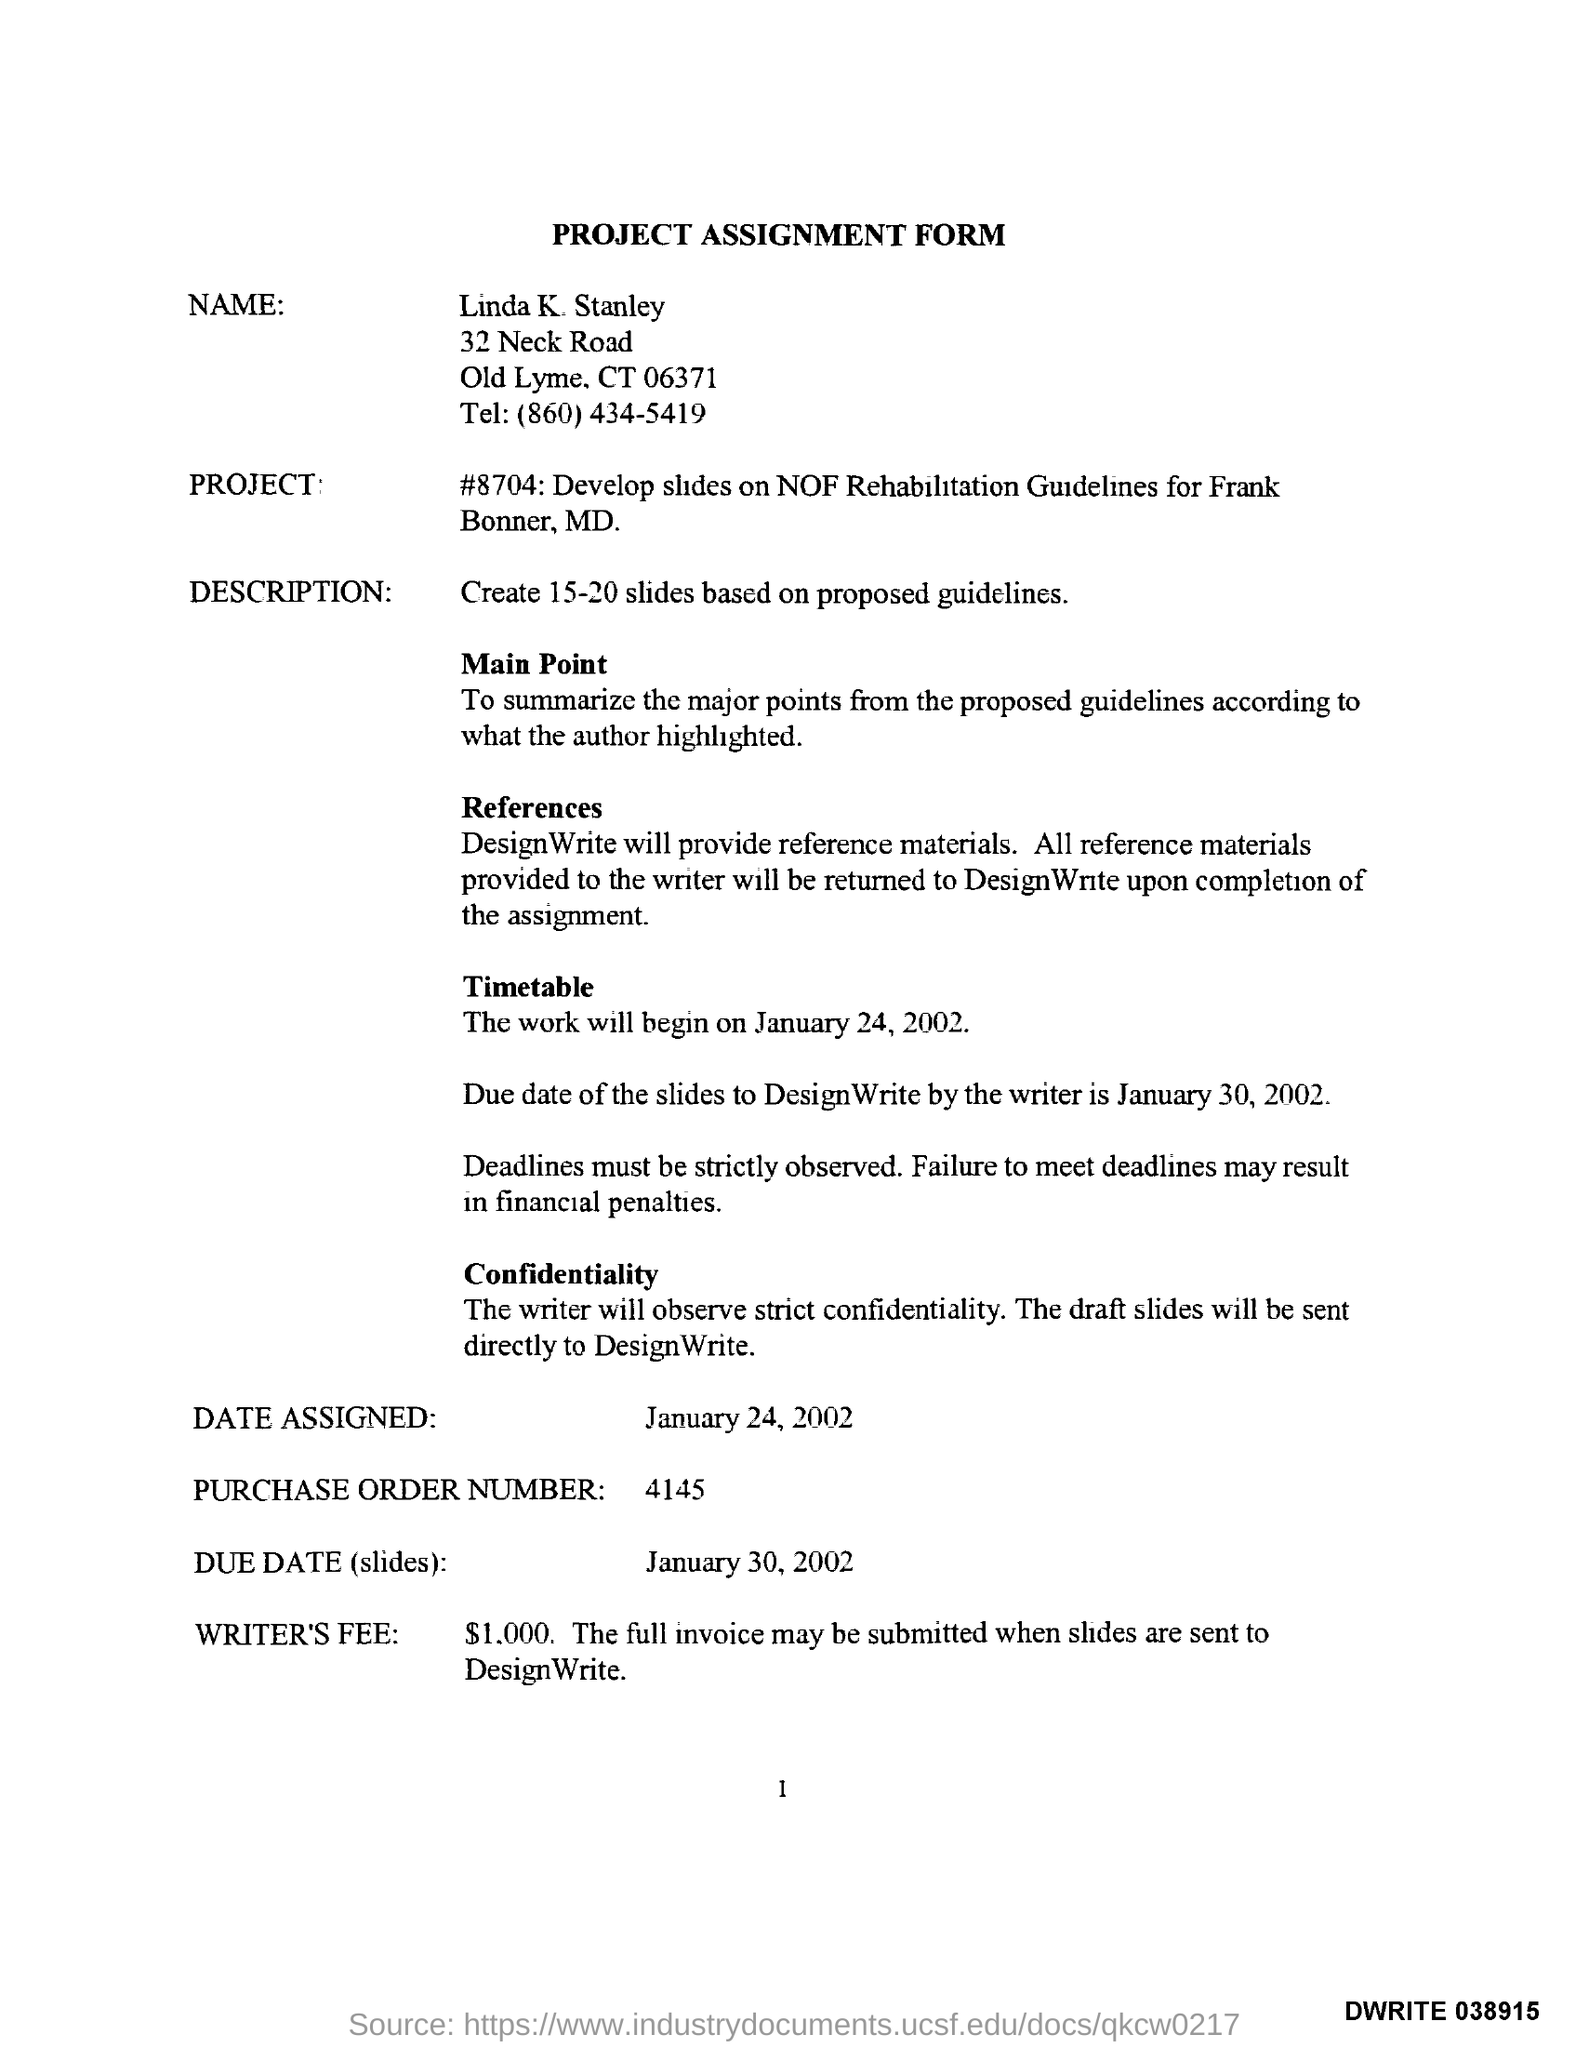Specify some key components in this picture. The purchase order number is 4145. The telephone number of Linda is 860-434-5419. The due date for the slides is January 30, 2002. The title of the document is 'Project Assignment Form.' 